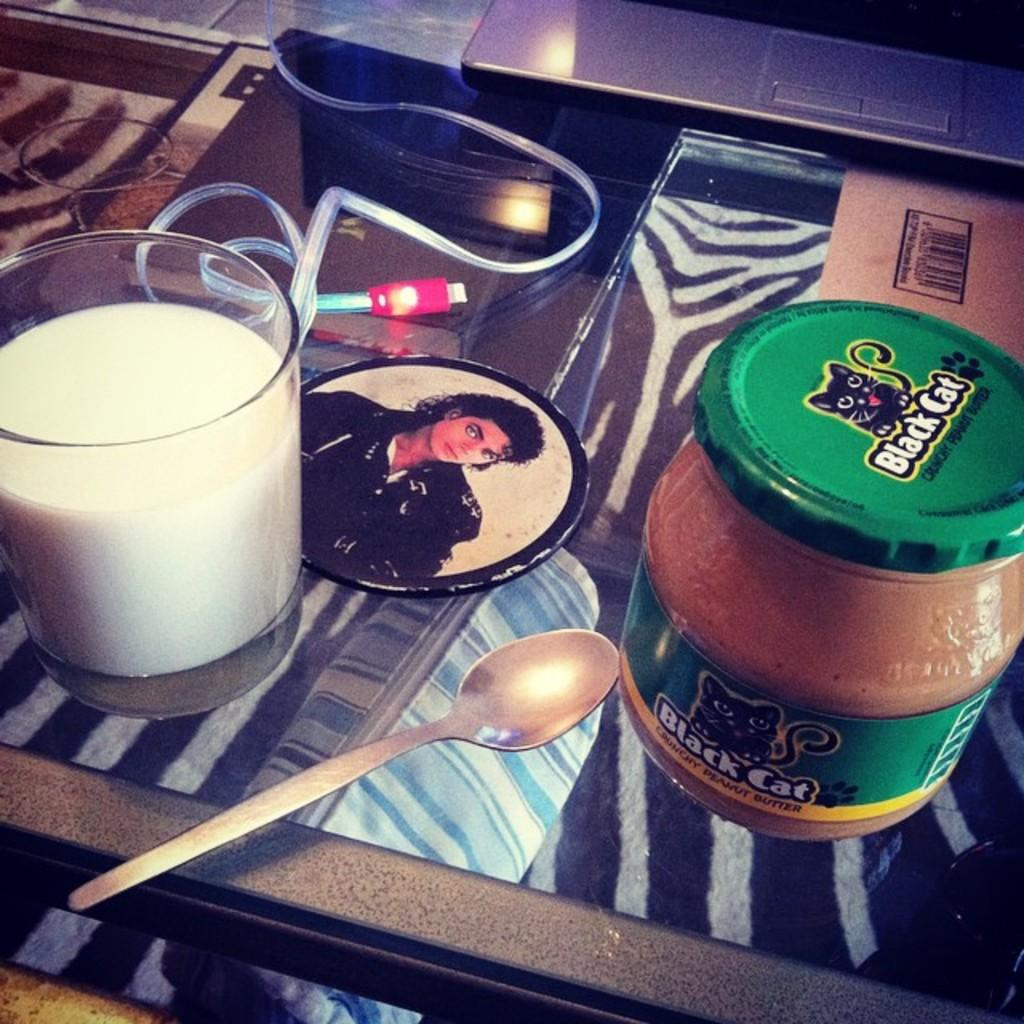What piece of furniture is present in the image? There is a table in the image. What is placed on the table? There is a glass of milk and a spoon on the table. Is there any other glass containing a substance on the table? Yes, there is a glass of butter on the table. What type of structure can be seen in the background of the image? There is no structure visible in the background of the image. Can you see any steam coming from the glass of milk in the image? There is no steam present in the image. 